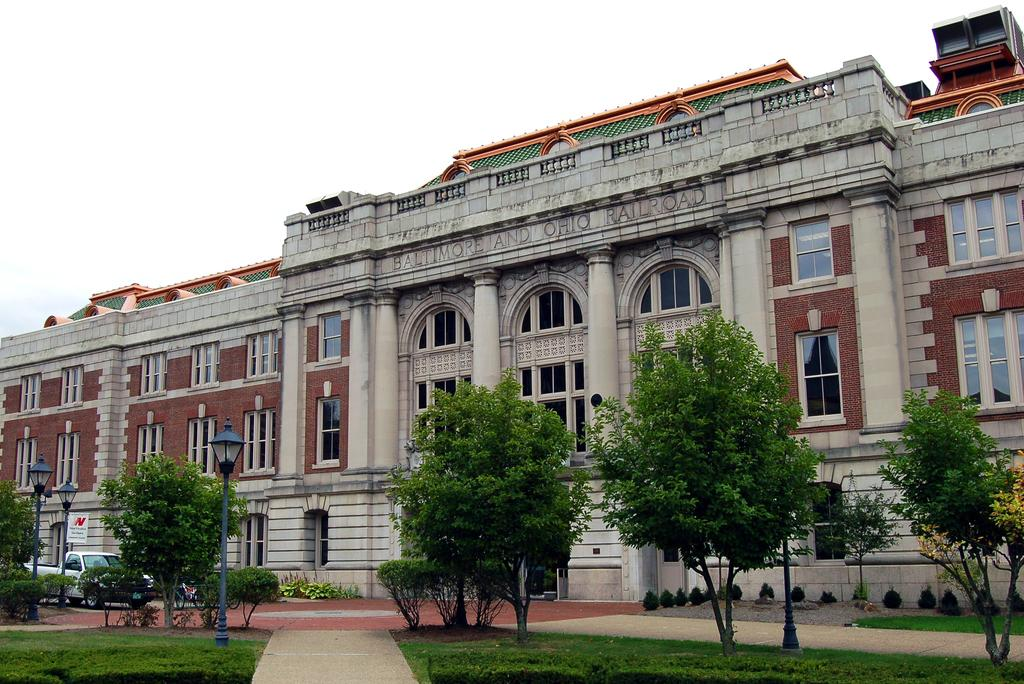What type of structure is in the image? There is a building in the image. What feature can be seen on the building? The building has glass windows. What natural elements are present in the image? There are trees and green grass in the image. What type of lighting is present in the image? Decorative light poles are present in the image. What can be used for walking or traversing in the image? Walkways are visible walkways are visible in the image. What type of holiday is being celebrated in the image? There is no indication of a holiday being celebrated in the image. Can you tell me the credit score of the person who designed the building? There is no information about the designer of the building, let alone their credit score. 